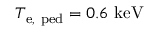<formula> <loc_0><loc_0><loc_500><loc_500>T _ { e , p e d } = 0 . 6 k e V</formula> 